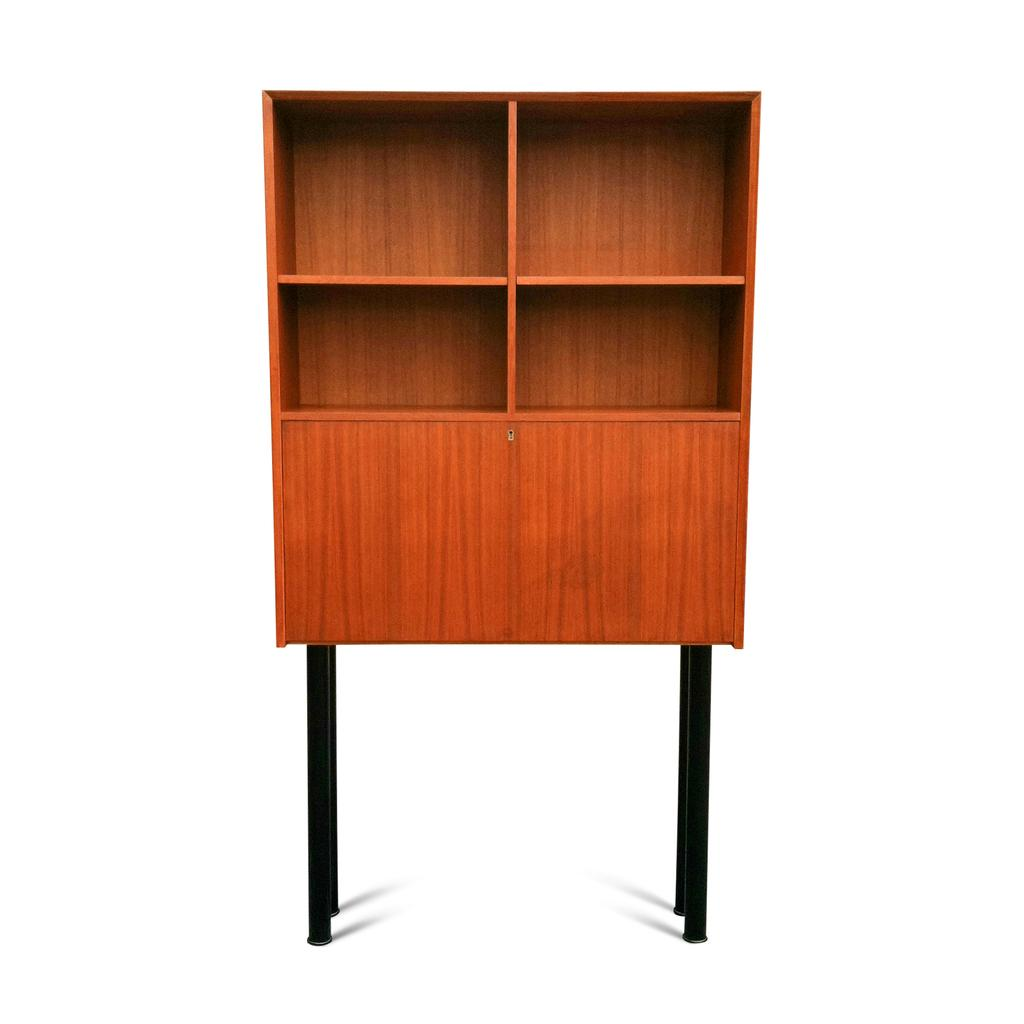How many black rods are present in the image? There are 4 black rods in the image. What is attached to the black rods? There is a brown color cupboard on the rods. What color is the background of the image? The background of the image is white. What type of feast is being prepared in the image? There is no indication of a feast or any food preparation in the image. How does the girl contribute to the health of the rods in the image? There is no girl present in the image, and the rods do not require any health-related assistance. 